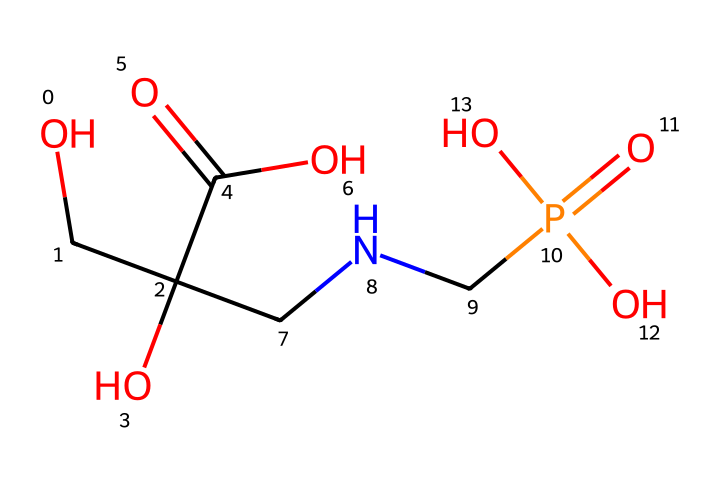What is the molecular formula of glyphosate? To find the molecular formula, we need to count the number of each type of atom in the structural formula represented by the SMILES. There are 3 carbon (C), 8 hydrogen (H), 4 oxygen (O), 1 nitrogen (N), and 1 phosphorus (P) atoms. This gives us the molecular formula C3H8N1O4P1.
Answer: C3H8N1O4P1 How many oxygen atoms are present in the structure? By analyzing the SMILES representation, we can detect the presence of oxygen atoms; there are 4 instances of the letter 'O' in the formula. Hence, there are four oxygen atoms in this chemical structure.
Answer: 4 What type of functional group is represented by C(=O)O in glyphosate? The structure C(=O)O indicates a carboxylic acid functional group, as it consists of a carbonyl (C=O) attached to a hydroxyl group (–OH). This functional group is characteristic of acids.
Answer: carboxylic acid How many nitrogen atoms are there in glyphosate? The SMILES representation includes one instance of the letter 'N', indicating that there is a single nitrogen atom present in the glyphosate structure.
Answer: 1 What characteristic does glyphosate have that makes it a herbicide? Glyphosate is recognized for its ability to inhibit a specific pathway in plants (the shikimic acid pathway), which is not found in animals, making it effective as a herbicide while being relatively safe for animal life.
Answer: inhibits shikimic acid pathway Which part of glyphosate contributes to its solubility in water? The presence of multiple hydroxyl groups (–OH) and the carboxylic acid functional group (C(=O)O) increases the polarity of glyphosate, making it soluble in water. The hydroxyl groups form hydrogen bonds with water molecules.
Answer: hydroxyl groups and carboxylic acid What is the role of phosphorus in glyphosate? The phosphorus atom in glyphosate is part of the phosphate group (P(=O)(O)(O)), which is vital for the connectivity and activity of the herbicide. This phosphate contributes to the stability and functionality of the molecule in its herbicidal action.
Answer: contributes to stability and functionality 